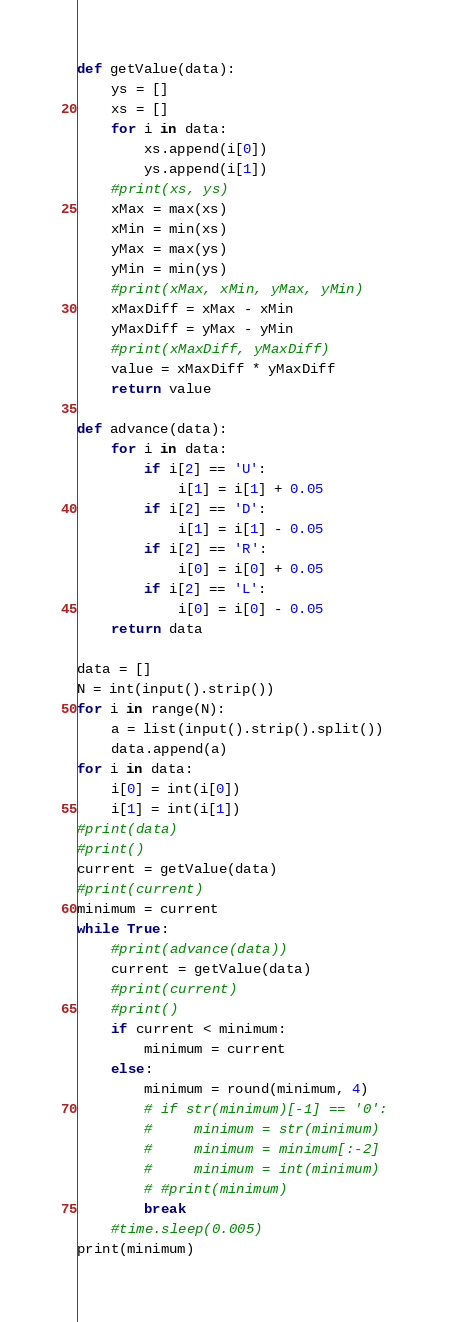<code> <loc_0><loc_0><loc_500><loc_500><_Python_>def getValue(data):
    ys = []
    xs = []
    for i in data:
        xs.append(i[0])
        ys.append(i[1])
    #print(xs, ys)
    xMax = max(xs)
    xMin = min(xs)
    yMax = max(ys)
    yMin = min(ys)
    #print(xMax, xMin, yMax, yMin)
    xMaxDiff = xMax - xMin
    yMaxDiff = yMax - yMin
    #print(xMaxDiff, yMaxDiff)
    value = xMaxDiff * yMaxDiff
    return value

def advance(data):
    for i in data:
        if i[2] == 'U':
            i[1] = i[1] + 0.05
        if i[2] == 'D':
            i[1] = i[1] - 0.05
        if i[2] == 'R':
            i[0] = i[0] + 0.05
        if i[2] == 'L':
            i[0] = i[0] - 0.05
    return data

data = []
N = int(input().strip())
for i in range(N):
    a = list(input().strip().split())
    data.append(a)
for i in data:
    i[0] = int(i[0])
    i[1] = int(i[1])
#print(data)
#print()
current = getValue(data)
#print(current)
minimum = current
while True:
    #print(advance(data))
    current = getValue(data)
    #print(current)
    #print()
    if current < minimum:
        minimum = current
    else:
        minimum = round(minimum, 4)
        # if str(minimum)[-1] == '0':
        #     minimum = str(minimum)
        #     minimum = minimum[:-2]
        #     minimum = int(minimum)
        # #print(minimum)
        break
    #time.sleep(0.005)
print(minimum)
</code> 